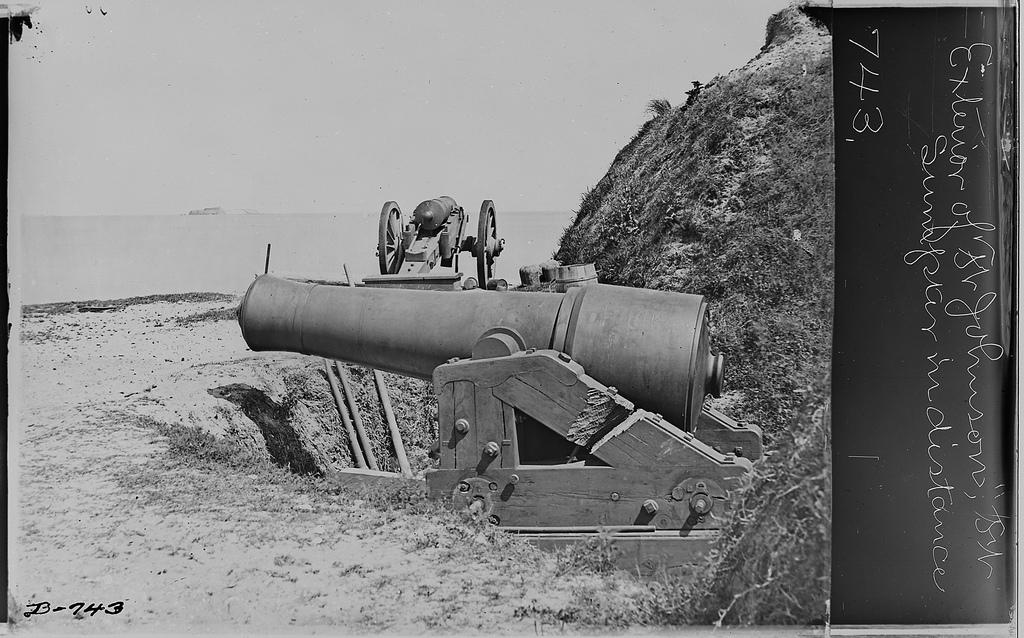What is the occupation of the person in the image? There is a mechanic in the image. Where is the mechanic located in the image? The mechanic is beside the road. What natural element can be seen in the image? There is water visible in the image. What type of underwear is the mechanic wearing in the image? There is no information about the mechanic's underwear in the image, and it is not appropriate to make assumptions about someone's clothing based on a photograph. 